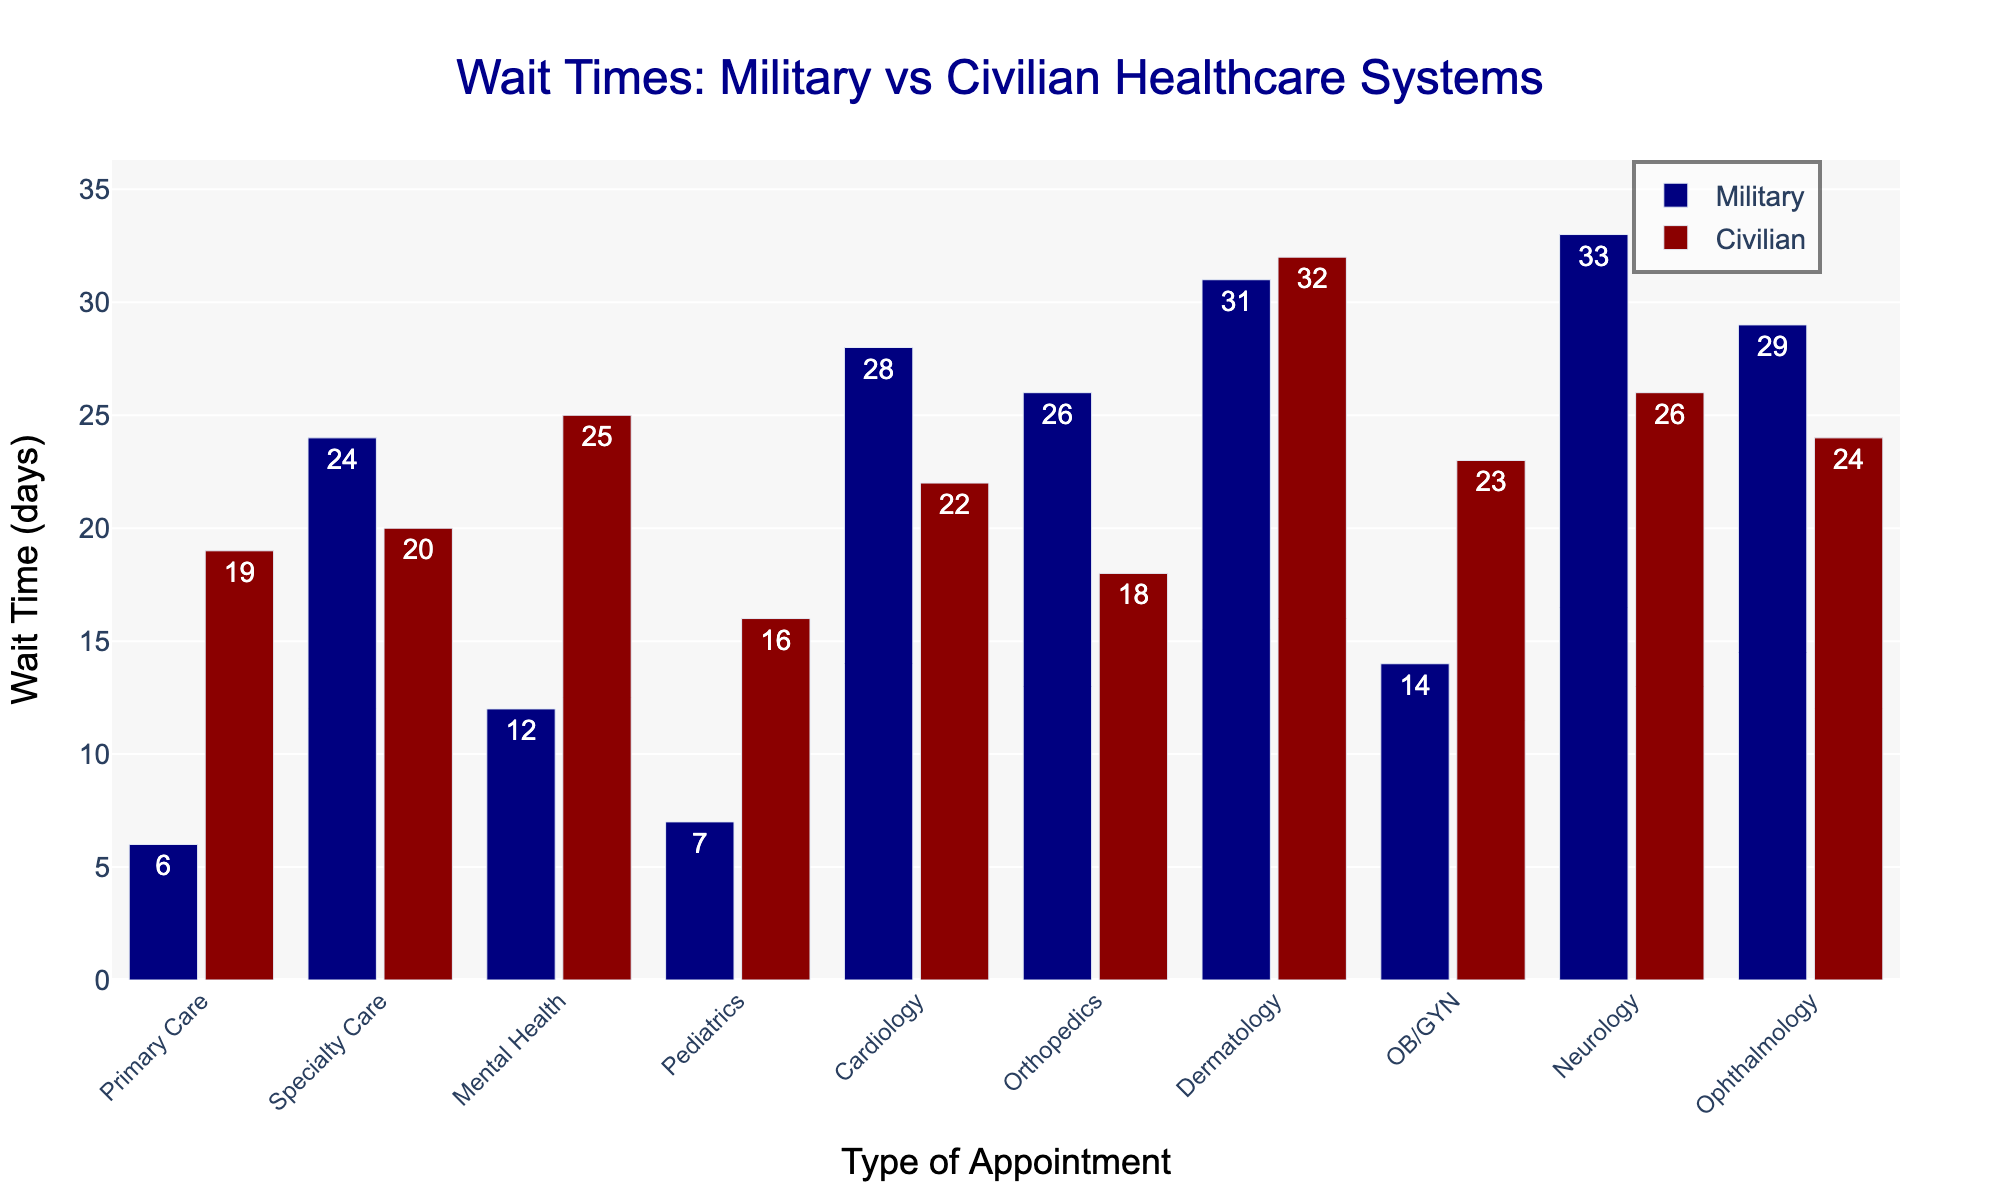Which type of appointment has the longest military wait time? The military wait times for all appointment types are listed. The highest value is the longest wait time; by checking each, Neurology has the longest wait with 33 days.
Answer: Neurology What's the difference in wait time between military and civilian for Primary Care appointments? The military wait time for Primary Care is 6 days, and the civilian wait time is 19 days. The difference is 19 - 6 = 13 days.
Answer: 13 days Which appointment type has a shorter wait time in the civilian system compared to the military system? Reviewing the chart, for Primary Care, Specialty Care, Pediatrics, Cardiology, Orthopedics, OB/GYN, and Neurology, military wait times are shorter. For Dermatology, mental health, military wait times are longer.
Answer: Primary Care, Pediatrics, Cardiology, Orthopedics For which appointment type is the wait time equal in both the military and civilian systems? Reviewing both bars for each appointment type, Dermatology has equal wait times in both the military and civilian systems with 31 and 32 days in military and civilian systems respectively.
Answer: Dermatology What's the average wait time for military and civilian systems for all types of appointments? First, sum all the wait times for each system and then divide by the number of appointment types (10). Military: (6+24+12+7+28+26+31+14+33+29)/10 = 21 days. Civilian: (19+20+25+16+22+18+32+23+26+24)/10 = 22.5 days.
Answer: Military: 21 days, Civilian: 22.5 days Compare the wait times for Mental Health appointments in military and civilian systems. Which one is higher? By looking at the Mental Health wait times, the military wait time is 12 days and the civilian wait time is 25 days. Therefore, the civilian system has higher wait times for mental health appointments.
Answer: Civilian Which appointment type shows the greatest difference in wait times between military and civilian systems? The differences are: Primary Care: 13, Specialty Care: 4, Mental Health: 13, Pediatrics: 9, Cardiology: 6, Orthopedics: 8, Dermatology: 1, OB/GYN: 9, Neurology: 7, Ophthalmology: 5. The greatest difference is 13 days for both Primary Care and Mental Health.
Answer: Primary Care, Mental Health Do any appointment types have a wait time of over 30 days in both systems? By scanning the chart, Neurology has 33 days in military and 26 days in civilian systems. Dermatology both systems have over 30 days (31 and 32 days respectively).
Answer: Dermatology 